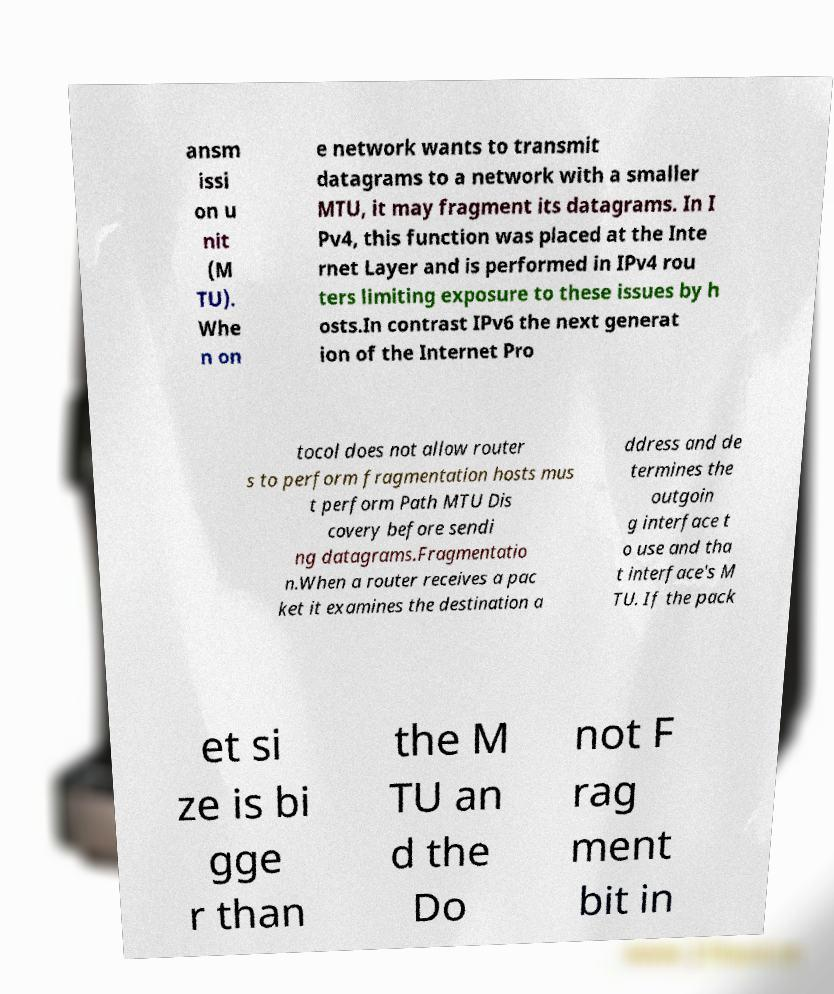Please read and relay the text visible in this image. What does it say? ansm issi on u nit (M TU). Whe n on e network wants to transmit datagrams to a network with a smaller MTU, it may fragment its datagrams. In I Pv4, this function was placed at the Inte rnet Layer and is performed in IPv4 rou ters limiting exposure to these issues by h osts.In contrast IPv6 the next generat ion of the Internet Pro tocol does not allow router s to perform fragmentation hosts mus t perform Path MTU Dis covery before sendi ng datagrams.Fragmentatio n.When a router receives a pac ket it examines the destination a ddress and de termines the outgoin g interface t o use and tha t interface's M TU. If the pack et si ze is bi gge r than the M TU an d the Do not F rag ment bit in 